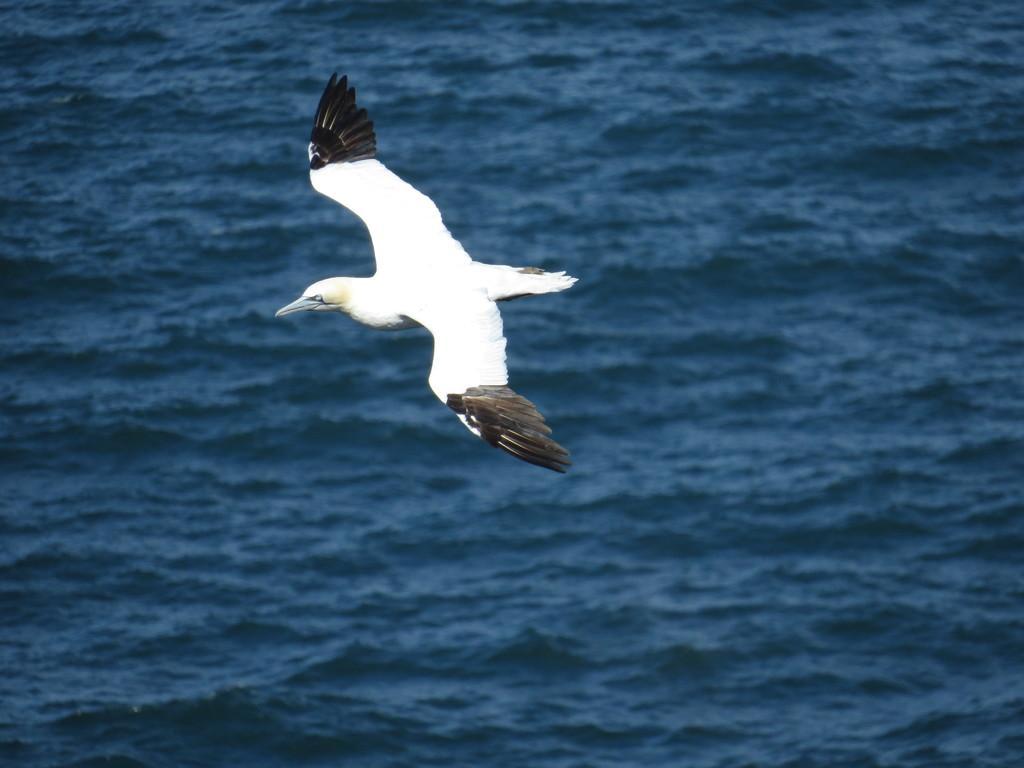In one or two sentences, can you explain what this image depicts? In this image we can see a bird in the air. There is a sea in the image. 